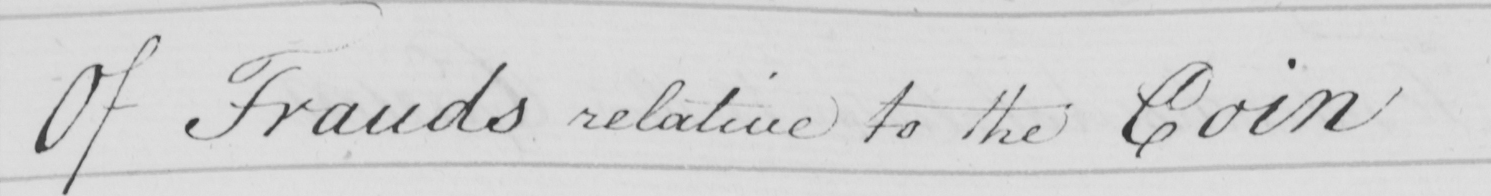Please transcribe the handwritten text in this image. Of Frauds relative to the Coin 